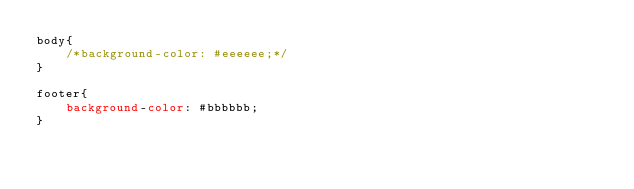<code> <loc_0><loc_0><loc_500><loc_500><_CSS_>body{
	/*background-color: #eeeeee;*/
}

footer{
	background-color: #bbbbbb;
}

</code> 